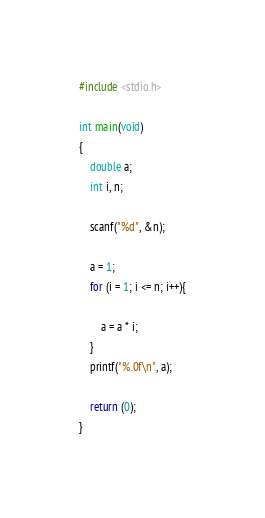Convert code to text. <code><loc_0><loc_0><loc_500><loc_500><_C_>#include <stdio.h>
 
int main(void)
{
	double a;
	int i, n;
	
	scanf("%d", &n);
	
	a = 1;
	for (i = 1; i <= n; i++){
		
		a = a * i;
	}
	printf("%.0f\n", a);
	
	return (0);
}</code> 